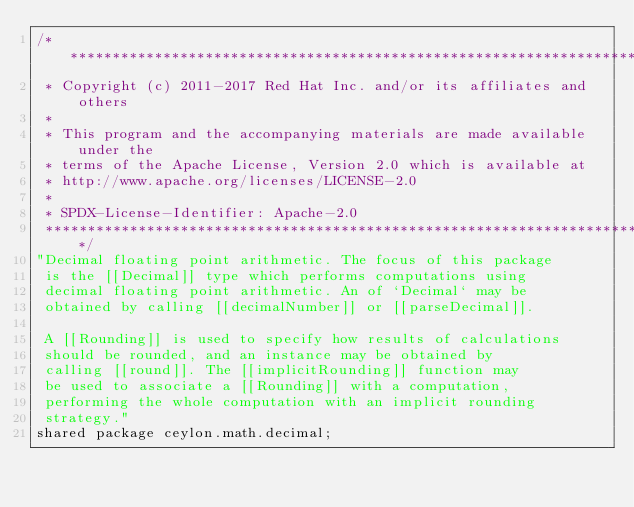Convert code to text. <code><loc_0><loc_0><loc_500><loc_500><_Ceylon_>/********************************************************************************
 * Copyright (c) 2011-2017 Red Hat Inc. and/or its affiliates and others
 *
 * This program and the accompanying materials are made available under the 
 * terms of the Apache License, Version 2.0 which is available at
 * http://www.apache.org/licenses/LICENSE-2.0
 *
 * SPDX-License-Identifier: Apache-2.0 
 ********************************************************************************/
"Decimal floating point arithmetic. The focus of this package 
 is the [[Decimal]] type which performs computations using 
 decimal floating point arithmetic. An of `Decimal` may be 
 obtained by calling [[decimalNumber]] or [[parseDecimal]].
 
 A [[Rounding]] is used to specify how results of calculations 
 should be rounded, and an instance may be obtained by 
 calling [[round]]. The [[implicitRounding]] function may
 be used to associate a [[Rounding]] with a computation, 
 performing the whole computation with an implicit rounding
 strategy."
shared package ceylon.math.decimal;
</code> 